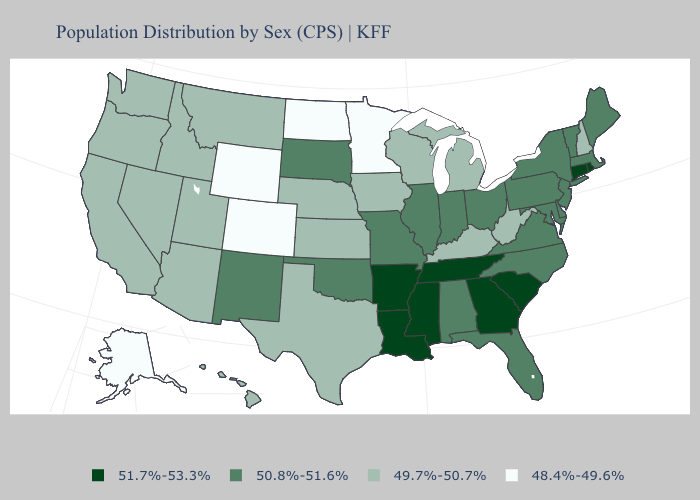Which states have the lowest value in the USA?
Give a very brief answer. Alaska, Colorado, Minnesota, North Dakota, Wyoming. What is the lowest value in the USA?
Write a very short answer. 48.4%-49.6%. What is the highest value in the Northeast ?
Answer briefly. 51.7%-53.3%. Which states hav the highest value in the Northeast?
Answer briefly. Connecticut, Rhode Island. What is the value of Utah?
Keep it brief. 49.7%-50.7%. What is the highest value in states that border South Dakota?
Short answer required. 49.7%-50.7%. Does New Hampshire have a higher value than Alaska?
Concise answer only. Yes. Name the states that have a value in the range 50.8%-51.6%?
Write a very short answer. Alabama, Delaware, Florida, Illinois, Indiana, Maine, Maryland, Massachusetts, Missouri, New Jersey, New Mexico, New York, North Carolina, Ohio, Oklahoma, Pennsylvania, South Dakota, Vermont, Virginia. What is the value of Oregon?
Keep it brief. 49.7%-50.7%. Does North Dakota have the lowest value in the USA?
Quick response, please. Yes. What is the value of Kansas?
Keep it brief. 49.7%-50.7%. Among the states that border Wisconsin , which have the lowest value?
Answer briefly. Minnesota. What is the value of Pennsylvania?
Quick response, please. 50.8%-51.6%. Which states hav the highest value in the Northeast?
Keep it brief. Connecticut, Rhode Island. Does Oregon have the highest value in the West?
Keep it brief. No. 